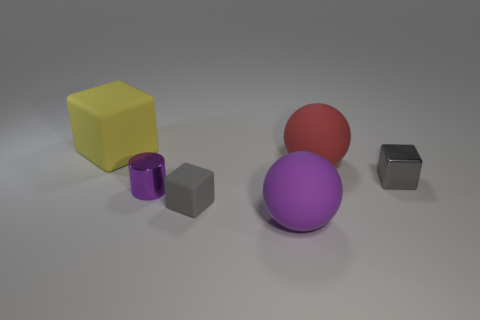There is a small thing that is the same material as the big yellow thing; what shape is it?
Your answer should be very brief. Cube. Does the big matte cube have the same color as the tiny metallic cylinder?
Make the answer very short. No. Does the small block right of the gray rubber object have the same material as the small gray cube left of the gray shiny block?
Ensure brevity in your answer.  No. How many objects are either purple metal cylinders or large objects that are to the right of the large cube?
Give a very brief answer. 3. What shape is the matte thing that is the same color as the metal cylinder?
Keep it short and to the point. Sphere. What is the purple cylinder made of?
Your response must be concise. Metal. Does the red ball have the same material as the cylinder?
Offer a terse response. No. What number of metal objects are yellow blocks or large cyan balls?
Your answer should be very brief. 0. The thing right of the red ball has what shape?
Make the answer very short. Cube. The yellow cube that is made of the same material as the big purple thing is what size?
Your response must be concise. Large. 